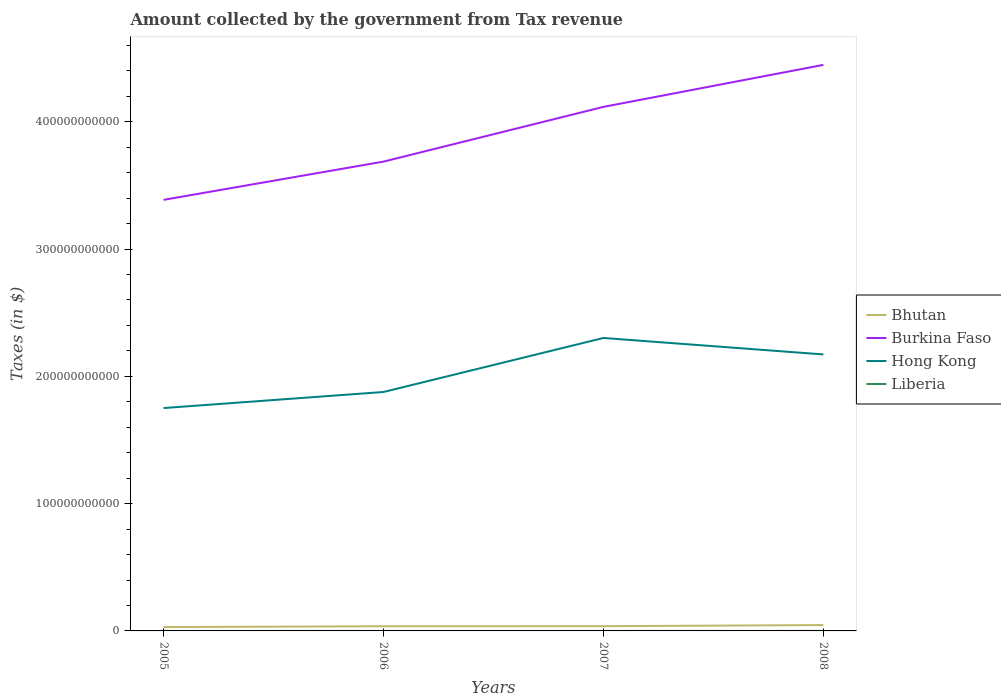Does the line corresponding to Bhutan intersect with the line corresponding to Hong Kong?
Make the answer very short. No. Is the number of lines equal to the number of legend labels?
Ensure brevity in your answer.  Yes. Across all years, what is the maximum amount collected by the government from tax revenue in Bhutan?
Provide a short and direct response. 3.01e+09. In which year was the amount collected by the government from tax revenue in Burkina Faso maximum?
Your answer should be compact. 2005. What is the total amount collected by the government from tax revenue in Burkina Faso in the graph?
Your answer should be compact. -7.60e+1. What is the difference between the highest and the second highest amount collected by the government from tax revenue in Hong Kong?
Provide a short and direct response. 5.51e+1. Is the amount collected by the government from tax revenue in Bhutan strictly greater than the amount collected by the government from tax revenue in Liberia over the years?
Your answer should be very brief. No. What is the difference between two consecutive major ticks on the Y-axis?
Offer a very short reply. 1.00e+11. Are the values on the major ticks of Y-axis written in scientific E-notation?
Provide a short and direct response. No. How many legend labels are there?
Ensure brevity in your answer.  4. How are the legend labels stacked?
Provide a succinct answer. Vertical. What is the title of the graph?
Make the answer very short. Amount collected by the government from Tax revenue. Does "Korea (Republic)" appear as one of the legend labels in the graph?
Your response must be concise. No. What is the label or title of the Y-axis?
Offer a terse response. Taxes (in $). What is the Taxes (in $) of Bhutan in 2005?
Provide a short and direct response. 3.01e+09. What is the Taxes (in $) in Burkina Faso in 2005?
Keep it short and to the point. 3.39e+11. What is the Taxes (in $) of Hong Kong in 2005?
Ensure brevity in your answer.  1.75e+11. What is the Taxes (in $) in Liberia in 2005?
Your answer should be compact. 1.27e+06. What is the Taxes (in $) in Bhutan in 2006?
Your answer should be very brief. 3.67e+09. What is the Taxes (in $) of Burkina Faso in 2006?
Your response must be concise. 3.69e+11. What is the Taxes (in $) in Hong Kong in 2006?
Your response must be concise. 1.88e+11. What is the Taxes (in $) in Liberia in 2006?
Make the answer very short. 1.40e+06. What is the Taxes (in $) of Bhutan in 2007?
Keep it short and to the point. 3.72e+09. What is the Taxes (in $) in Burkina Faso in 2007?
Ensure brevity in your answer.  4.12e+11. What is the Taxes (in $) in Hong Kong in 2007?
Offer a terse response. 2.30e+11. What is the Taxes (in $) in Liberia in 2007?
Ensure brevity in your answer.  2.29e+06. What is the Taxes (in $) of Bhutan in 2008?
Make the answer very short. 4.61e+09. What is the Taxes (in $) of Burkina Faso in 2008?
Provide a short and direct response. 4.45e+11. What is the Taxes (in $) in Hong Kong in 2008?
Provide a short and direct response. 2.17e+11. What is the Taxes (in $) of Liberia in 2008?
Offer a very short reply. 2.69e+06. Across all years, what is the maximum Taxes (in $) in Bhutan?
Offer a terse response. 4.61e+09. Across all years, what is the maximum Taxes (in $) of Burkina Faso?
Your answer should be compact. 4.45e+11. Across all years, what is the maximum Taxes (in $) in Hong Kong?
Your answer should be very brief. 2.30e+11. Across all years, what is the maximum Taxes (in $) of Liberia?
Your answer should be very brief. 2.69e+06. Across all years, what is the minimum Taxes (in $) in Bhutan?
Give a very brief answer. 3.01e+09. Across all years, what is the minimum Taxes (in $) in Burkina Faso?
Offer a very short reply. 3.39e+11. Across all years, what is the minimum Taxes (in $) of Hong Kong?
Offer a very short reply. 1.75e+11. Across all years, what is the minimum Taxes (in $) of Liberia?
Keep it short and to the point. 1.27e+06. What is the total Taxes (in $) in Bhutan in the graph?
Your answer should be compact. 1.50e+1. What is the total Taxes (in $) in Burkina Faso in the graph?
Your answer should be very brief. 1.56e+12. What is the total Taxes (in $) of Hong Kong in the graph?
Offer a terse response. 8.10e+11. What is the total Taxes (in $) of Liberia in the graph?
Keep it short and to the point. 7.64e+06. What is the difference between the Taxes (in $) in Bhutan in 2005 and that in 2006?
Offer a very short reply. -6.59e+08. What is the difference between the Taxes (in $) of Burkina Faso in 2005 and that in 2006?
Keep it short and to the point. -3.00e+1. What is the difference between the Taxes (in $) in Hong Kong in 2005 and that in 2006?
Give a very brief answer. -1.26e+1. What is the difference between the Taxes (in $) in Liberia in 2005 and that in 2006?
Make the answer very short. -1.25e+05. What is the difference between the Taxes (in $) in Bhutan in 2005 and that in 2007?
Give a very brief answer. -7.05e+08. What is the difference between the Taxes (in $) in Burkina Faso in 2005 and that in 2007?
Offer a very short reply. -7.30e+1. What is the difference between the Taxes (in $) of Hong Kong in 2005 and that in 2007?
Provide a succinct answer. -5.51e+1. What is the difference between the Taxes (in $) in Liberia in 2005 and that in 2007?
Keep it short and to the point. -1.02e+06. What is the difference between the Taxes (in $) in Bhutan in 2005 and that in 2008?
Your answer should be compact. -1.59e+09. What is the difference between the Taxes (in $) in Burkina Faso in 2005 and that in 2008?
Provide a short and direct response. -1.06e+11. What is the difference between the Taxes (in $) of Hong Kong in 2005 and that in 2008?
Your answer should be compact. -4.21e+1. What is the difference between the Taxes (in $) of Liberia in 2005 and that in 2008?
Provide a short and direct response. -1.42e+06. What is the difference between the Taxes (in $) of Bhutan in 2006 and that in 2007?
Make the answer very short. -4.57e+07. What is the difference between the Taxes (in $) in Burkina Faso in 2006 and that in 2007?
Provide a short and direct response. -4.30e+1. What is the difference between the Taxes (in $) in Hong Kong in 2006 and that in 2007?
Make the answer very short. -4.24e+1. What is the difference between the Taxes (in $) in Liberia in 2006 and that in 2007?
Provide a succinct answer. -8.90e+05. What is the difference between the Taxes (in $) in Bhutan in 2006 and that in 2008?
Ensure brevity in your answer.  -9.34e+08. What is the difference between the Taxes (in $) of Burkina Faso in 2006 and that in 2008?
Make the answer very short. -7.60e+1. What is the difference between the Taxes (in $) in Hong Kong in 2006 and that in 2008?
Your response must be concise. -2.95e+1. What is the difference between the Taxes (in $) of Liberia in 2006 and that in 2008?
Offer a very short reply. -1.29e+06. What is the difference between the Taxes (in $) of Bhutan in 2007 and that in 2008?
Your answer should be very brief. -8.88e+08. What is the difference between the Taxes (in $) of Burkina Faso in 2007 and that in 2008?
Your response must be concise. -3.30e+1. What is the difference between the Taxes (in $) in Hong Kong in 2007 and that in 2008?
Provide a short and direct response. 1.29e+1. What is the difference between the Taxes (in $) of Liberia in 2007 and that in 2008?
Make the answer very short. -4.02e+05. What is the difference between the Taxes (in $) in Bhutan in 2005 and the Taxes (in $) in Burkina Faso in 2006?
Your response must be concise. -3.66e+11. What is the difference between the Taxes (in $) in Bhutan in 2005 and the Taxes (in $) in Hong Kong in 2006?
Offer a very short reply. -1.85e+11. What is the difference between the Taxes (in $) in Bhutan in 2005 and the Taxes (in $) in Liberia in 2006?
Make the answer very short. 3.01e+09. What is the difference between the Taxes (in $) of Burkina Faso in 2005 and the Taxes (in $) of Hong Kong in 2006?
Give a very brief answer. 1.51e+11. What is the difference between the Taxes (in $) in Burkina Faso in 2005 and the Taxes (in $) in Liberia in 2006?
Offer a terse response. 3.39e+11. What is the difference between the Taxes (in $) of Hong Kong in 2005 and the Taxes (in $) of Liberia in 2006?
Ensure brevity in your answer.  1.75e+11. What is the difference between the Taxes (in $) of Bhutan in 2005 and the Taxes (in $) of Burkina Faso in 2007?
Give a very brief answer. -4.09e+11. What is the difference between the Taxes (in $) of Bhutan in 2005 and the Taxes (in $) of Hong Kong in 2007?
Your response must be concise. -2.27e+11. What is the difference between the Taxes (in $) of Bhutan in 2005 and the Taxes (in $) of Liberia in 2007?
Make the answer very short. 3.01e+09. What is the difference between the Taxes (in $) in Burkina Faso in 2005 and the Taxes (in $) in Hong Kong in 2007?
Make the answer very short. 1.09e+11. What is the difference between the Taxes (in $) of Burkina Faso in 2005 and the Taxes (in $) of Liberia in 2007?
Provide a succinct answer. 3.39e+11. What is the difference between the Taxes (in $) of Hong Kong in 2005 and the Taxes (in $) of Liberia in 2007?
Provide a succinct answer. 1.75e+11. What is the difference between the Taxes (in $) in Bhutan in 2005 and the Taxes (in $) in Burkina Faso in 2008?
Make the answer very short. -4.42e+11. What is the difference between the Taxes (in $) in Bhutan in 2005 and the Taxes (in $) in Hong Kong in 2008?
Your response must be concise. -2.14e+11. What is the difference between the Taxes (in $) of Bhutan in 2005 and the Taxes (in $) of Liberia in 2008?
Ensure brevity in your answer.  3.01e+09. What is the difference between the Taxes (in $) in Burkina Faso in 2005 and the Taxes (in $) in Hong Kong in 2008?
Your answer should be compact. 1.21e+11. What is the difference between the Taxes (in $) in Burkina Faso in 2005 and the Taxes (in $) in Liberia in 2008?
Your answer should be very brief. 3.39e+11. What is the difference between the Taxes (in $) of Hong Kong in 2005 and the Taxes (in $) of Liberia in 2008?
Make the answer very short. 1.75e+11. What is the difference between the Taxes (in $) of Bhutan in 2006 and the Taxes (in $) of Burkina Faso in 2007?
Your response must be concise. -4.08e+11. What is the difference between the Taxes (in $) of Bhutan in 2006 and the Taxes (in $) of Hong Kong in 2007?
Keep it short and to the point. -2.26e+11. What is the difference between the Taxes (in $) in Bhutan in 2006 and the Taxes (in $) in Liberia in 2007?
Your answer should be very brief. 3.67e+09. What is the difference between the Taxes (in $) of Burkina Faso in 2006 and the Taxes (in $) of Hong Kong in 2007?
Offer a terse response. 1.39e+11. What is the difference between the Taxes (in $) in Burkina Faso in 2006 and the Taxes (in $) in Liberia in 2007?
Provide a succinct answer. 3.69e+11. What is the difference between the Taxes (in $) of Hong Kong in 2006 and the Taxes (in $) of Liberia in 2007?
Offer a terse response. 1.88e+11. What is the difference between the Taxes (in $) of Bhutan in 2006 and the Taxes (in $) of Burkina Faso in 2008?
Give a very brief answer. -4.41e+11. What is the difference between the Taxes (in $) in Bhutan in 2006 and the Taxes (in $) in Hong Kong in 2008?
Give a very brief answer. -2.14e+11. What is the difference between the Taxes (in $) in Bhutan in 2006 and the Taxes (in $) in Liberia in 2008?
Offer a very short reply. 3.67e+09. What is the difference between the Taxes (in $) of Burkina Faso in 2006 and the Taxes (in $) of Hong Kong in 2008?
Ensure brevity in your answer.  1.51e+11. What is the difference between the Taxes (in $) of Burkina Faso in 2006 and the Taxes (in $) of Liberia in 2008?
Offer a terse response. 3.69e+11. What is the difference between the Taxes (in $) in Hong Kong in 2006 and the Taxes (in $) in Liberia in 2008?
Offer a very short reply. 1.88e+11. What is the difference between the Taxes (in $) in Bhutan in 2007 and the Taxes (in $) in Burkina Faso in 2008?
Offer a very short reply. -4.41e+11. What is the difference between the Taxes (in $) in Bhutan in 2007 and the Taxes (in $) in Hong Kong in 2008?
Give a very brief answer. -2.13e+11. What is the difference between the Taxes (in $) in Bhutan in 2007 and the Taxes (in $) in Liberia in 2008?
Your answer should be compact. 3.72e+09. What is the difference between the Taxes (in $) of Burkina Faso in 2007 and the Taxes (in $) of Hong Kong in 2008?
Offer a very short reply. 1.94e+11. What is the difference between the Taxes (in $) of Burkina Faso in 2007 and the Taxes (in $) of Liberia in 2008?
Offer a terse response. 4.12e+11. What is the difference between the Taxes (in $) of Hong Kong in 2007 and the Taxes (in $) of Liberia in 2008?
Offer a very short reply. 2.30e+11. What is the average Taxes (in $) in Bhutan per year?
Keep it short and to the point. 3.75e+09. What is the average Taxes (in $) of Burkina Faso per year?
Offer a terse response. 3.91e+11. What is the average Taxes (in $) in Hong Kong per year?
Your response must be concise. 2.03e+11. What is the average Taxes (in $) of Liberia per year?
Your answer should be compact. 1.91e+06. In the year 2005, what is the difference between the Taxes (in $) in Bhutan and Taxes (in $) in Burkina Faso?
Keep it short and to the point. -3.36e+11. In the year 2005, what is the difference between the Taxes (in $) in Bhutan and Taxes (in $) in Hong Kong?
Keep it short and to the point. -1.72e+11. In the year 2005, what is the difference between the Taxes (in $) in Bhutan and Taxes (in $) in Liberia?
Offer a terse response. 3.01e+09. In the year 2005, what is the difference between the Taxes (in $) of Burkina Faso and Taxes (in $) of Hong Kong?
Provide a short and direct response. 1.64e+11. In the year 2005, what is the difference between the Taxes (in $) in Burkina Faso and Taxes (in $) in Liberia?
Ensure brevity in your answer.  3.39e+11. In the year 2005, what is the difference between the Taxes (in $) in Hong Kong and Taxes (in $) in Liberia?
Your answer should be compact. 1.75e+11. In the year 2006, what is the difference between the Taxes (in $) in Bhutan and Taxes (in $) in Burkina Faso?
Make the answer very short. -3.65e+11. In the year 2006, what is the difference between the Taxes (in $) of Bhutan and Taxes (in $) of Hong Kong?
Make the answer very short. -1.84e+11. In the year 2006, what is the difference between the Taxes (in $) in Bhutan and Taxes (in $) in Liberia?
Your answer should be very brief. 3.67e+09. In the year 2006, what is the difference between the Taxes (in $) in Burkina Faso and Taxes (in $) in Hong Kong?
Provide a succinct answer. 1.81e+11. In the year 2006, what is the difference between the Taxes (in $) in Burkina Faso and Taxes (in $) in Liberia?
Keep it short and to the point. 3.69e+11. In the year 2006, what is the difference between the Taxes (in $) in Hong Kong and Taxes (in $) in Liberia?
Give a very brief answer. 1.88e+11. In the year 2007, what is the difference between the Taxes (in $) in Bhutan and Taxes (in $) in Burkina Faso?
Make the answer very short. -4.08e+11. In the year 2007, what is the difference between the Taxes (in $) of Bhutan and Taxes (in $) of Hong Kong?
Your response must be concise. -2.26e+11. In the year 2007, what is the difference between the Taxes (in $) in Bhutan and Taxes (in $) in Liberia?
Provide a succinct answer. 3.72e+09. In the year 2007, what is the difference between the Taxes (in $) in Burkina Faso and Taxes (in $) in Hong Kong?
Keep it short and to the point. 1.82e+11. In the year 2007, what is the difference between the Taxes (in $) of Burkina Faso and Taxes (in $) of Liberia?
Provide a succinct answer. 4.12e+11. In the year 2007, what is the difference between the Taxes (in $) of Hong Kong and Taxes (in $) of Liberia?
Ensure brevity in your answer.  2.30e+11. In the year 2008, what is the difference between the Taxes (in $) in Bhutan and Taxes (in $) in Burkina Faso?
Offer a terse response. -4.40e+11. In the year 2008, what is the difference between the Taxes (in $) in Bhutan and Taxes (in $) in Hong Kong?
Your answer should be compact. -2.13e+11. In the year 2008, what is the difference between the Taxes (in $) of Bhutan and Taxes (in $) of Liberia?
Make the answer very short. 4.60e+09. In the year 2008, what is the difference between the Taxes (in $) of Burkina Faso and Taxes (in $) of Hong Kong?
Your answer should be compact. 2.27e+11. In the year 2008, what is the difference between the Taxes (in $) of Burkina Faso and Taxes (in $) of Liberia?
Give a very brief answer. 4.45e+11. In the year 2008, what is the difference between the Taxes (in $) in Hong Kong and Taxes (in $) in Liberia?
Your response must be concise. 2.17e+11. What is the ratio of the Taxes (in $) in Bhutan in 2005 to that in 2006?
Keep it short and to the point. 0.82. What is the ratio of the Taxes (in $) of Burkina Faso in 2005 to that in 2006?
Provide a short and direct response. 0.92. What is the ratio of the Taxes (in $) in Hong Kong in 2005 to that in 2006?
Provide a short and direct response. 0.93. What is the ratio of the Taxes (in $) in Liberia in 2005 to that in 2006?
Make the answer very short. 0.91. What is the ratio of the Taxes (in $) in Bhutan in 2005 to that in 2007?
Offer a very short reply. 0.81. What is the ratio of the Taxes (in $) of Burkina Faso in 2005 to that in 2007?
Ensure brevity in your answer.  0.82. What is the ratio of the Taxes (in $) of Hong Kong in 2005 to that in 2007?
Your answer should be very brief. 0.76. What is the ratio of the Taxes (in $) in Liberia in 2005 to that in 2007?
Your answer should be compact. 0.56. What is the ratio of the Taxes (in $) of Bhutan in 2005 to that in 2008?
Provide a succinct answer. 0.65. What is the ratio of the Taxes (in $) of Burkina Faso in 2005 to that in 2008?
Offer a very short reply. 0.76. What is the ratio of the Taxes (in $) of Hong Kong in 2005 to that in 2008?
Keep it short and to the point. 0.81. What is the ratio of the Taxes (in $) in Liberia in 2005 to that in 2008?
Offer a terse response. 0.47. What is the ratio of the Taxes (in $) in Burkina Faso in 2006 to that in 2007?
Provide a succinct answer. 0.9. What is the ratio of the Taxes (in $) of Hong Kong in 2006 to that in 2007?
Your response must be concise. 0.82. What is the ratio of the Taxes (in $) in Liberia in 2006 to that in 2007?
Your answer should be very brief. 0.61. What is the ratio of the Taxes (in $) in Bhutan in 2006 to that in 2008?
Your answer should be compact. 0.8. What is the ratio of the Taxes (in $) of Burkina Faso in 2006 to that in 2008?
Make the answer very short. 0.83. What is the ratio of the Taxes (in $) of Hong Kong in 2006 to that in 2008?
Provide a short and direct response. 0.86. What is the ratio of the Taxes (in $) of Liberia in 2006 to that in 2008?
Offer a terse response. 0.52. What is the ratio of the Taxes (in $) of Bhutan in 2007 to that in 2008?
Your answer should be compact. 0.81. What is the ratio of the Taxes (in $) of Burkina Faso in 2007 to that in 2008?
Keep it short and to the point. 0.93. What is the ratio of the Taxes (in $) of Hong Kong in 2007 to that in 2008?
Keep it short and to the point. 1.06. What is the ratio of the Taxes (in $) in Liberia in 2007 to that in 2008?
Provide a short and direct response. 0.85. What is the difference between the highest and the second highest Taxes (in $) of Bhutan?
Your answer should be very brief. 8.88e+08. What is the difference between the highest and the second highest Taxes (in $) in Burkina Faso?
Make the answer very short. 3.30e+1. What is the difference between the highest and the second highest Taxes (in $) of Hong Kong?
Your answer should be very brief. 1.29e+1. What is the difference between the highest and the second highest Taxes (in $) of Liberia?
Give a very brief answer. 4.02e+05. What is the difference between the highest and the lowest Taxes (in $) in Bhutan?
Offer a terse response. 1.59e+09. What is the difference between the highest and the lowest Taxes (in $) in Burkina Faso?
Give a very brief answer. 1.06e+11. What is the difference between the highest and the lowest Taxes (in $) in Hong Kong?
Keep it short and to the point. 5.51e+1. What is the difference between the highest and the lowest Taxes (in $) in Liberia?
Keep it short and to the point. 1.42e+06. 